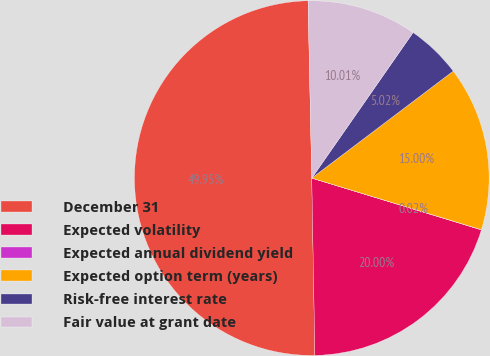Convert chart. <chart><loc_0><loc_0><loc_500><loc_500><pie_chart><fcel>December 31<fcel>Expected volatility<fcel>Expected annual dividend yield<fcel>Expected option term (years)<fcel>Risk-free interest rate<fcel>Fair value at grant date<nl><fcel>49.95%<fcel>20.0%<fcel>0.02%<fcel>15.0%<fcel>5.02%<fcel>10.01%<nl></chart> 